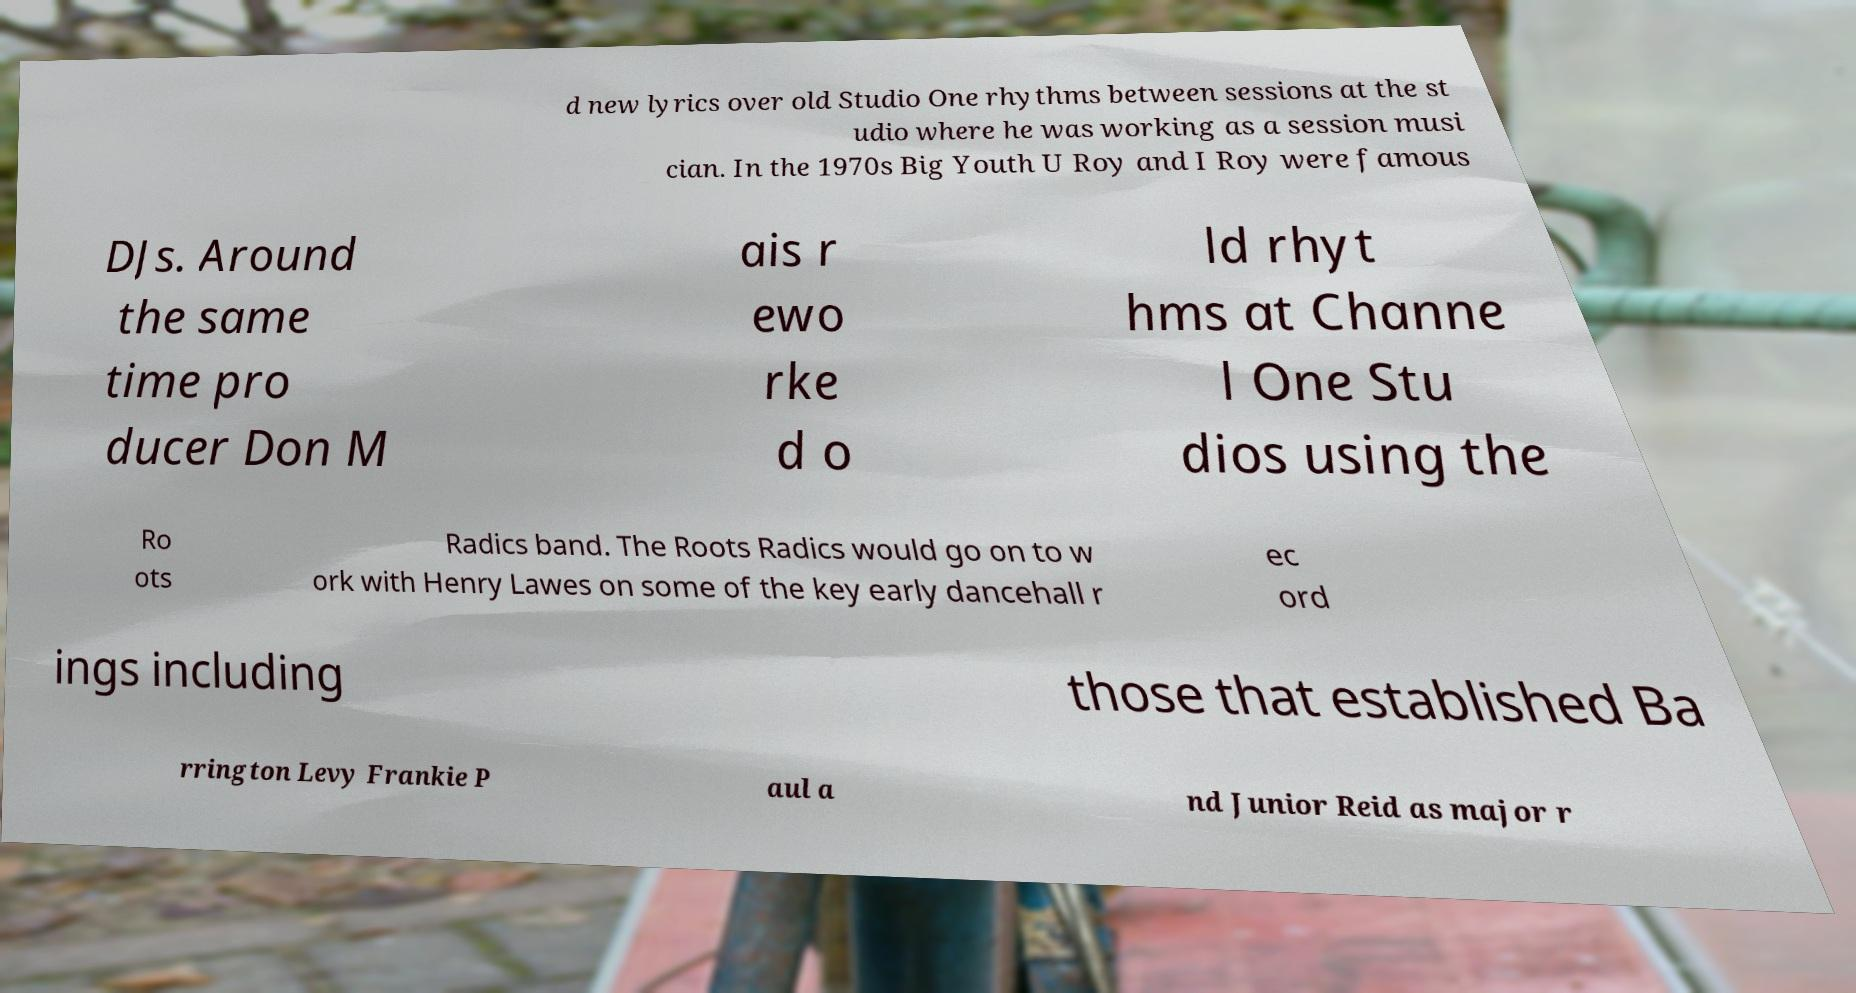Please identify and transcribe the text found in this image. d new lyrics over old Studio One rhythms between sessions at the st udio where he was working as a session musi cian. In the 1970s Big Youth U Roy and I Roy were famous DJs. Around the same time pro ducer Don M ais r ewo rke d o ld rhyt hms at Channe l One Stu dios using the Ro ots Radics band. The Roots Radics would go on to w ork with Henry Lawes on some of the key early dancehall r ec ord ings including those that established Ba rrington Levy Frankie P aul a nd Junior Reid as major r 